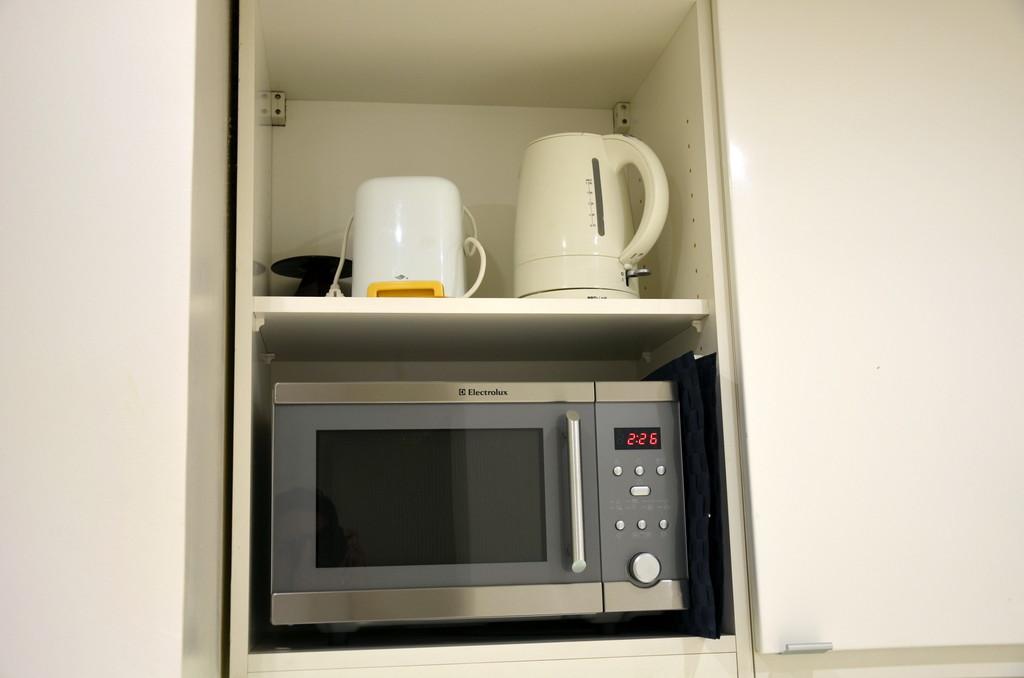What time is displayed on the microwave?
Provide a short and direct response. 2:26. What brand of microwave is this?
Your answer should be compact. Electrolux. 